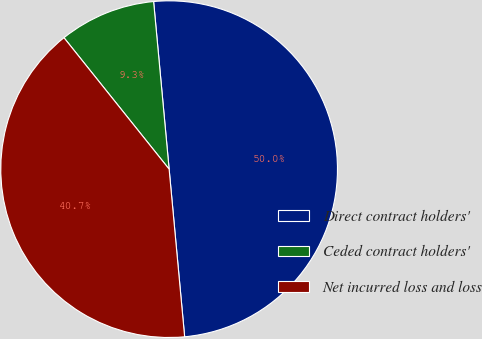Convert chart. <chart><loc_0><loc_0><loc_500><loc_500><pie_chart><fcel>Direct contract holders'<fcel>Ceded contract holders'<fcel>Net incurred loss and loss<nl><fcel>50.0%<fcel>9.27%<fcel>40.73%<nl></chart> 